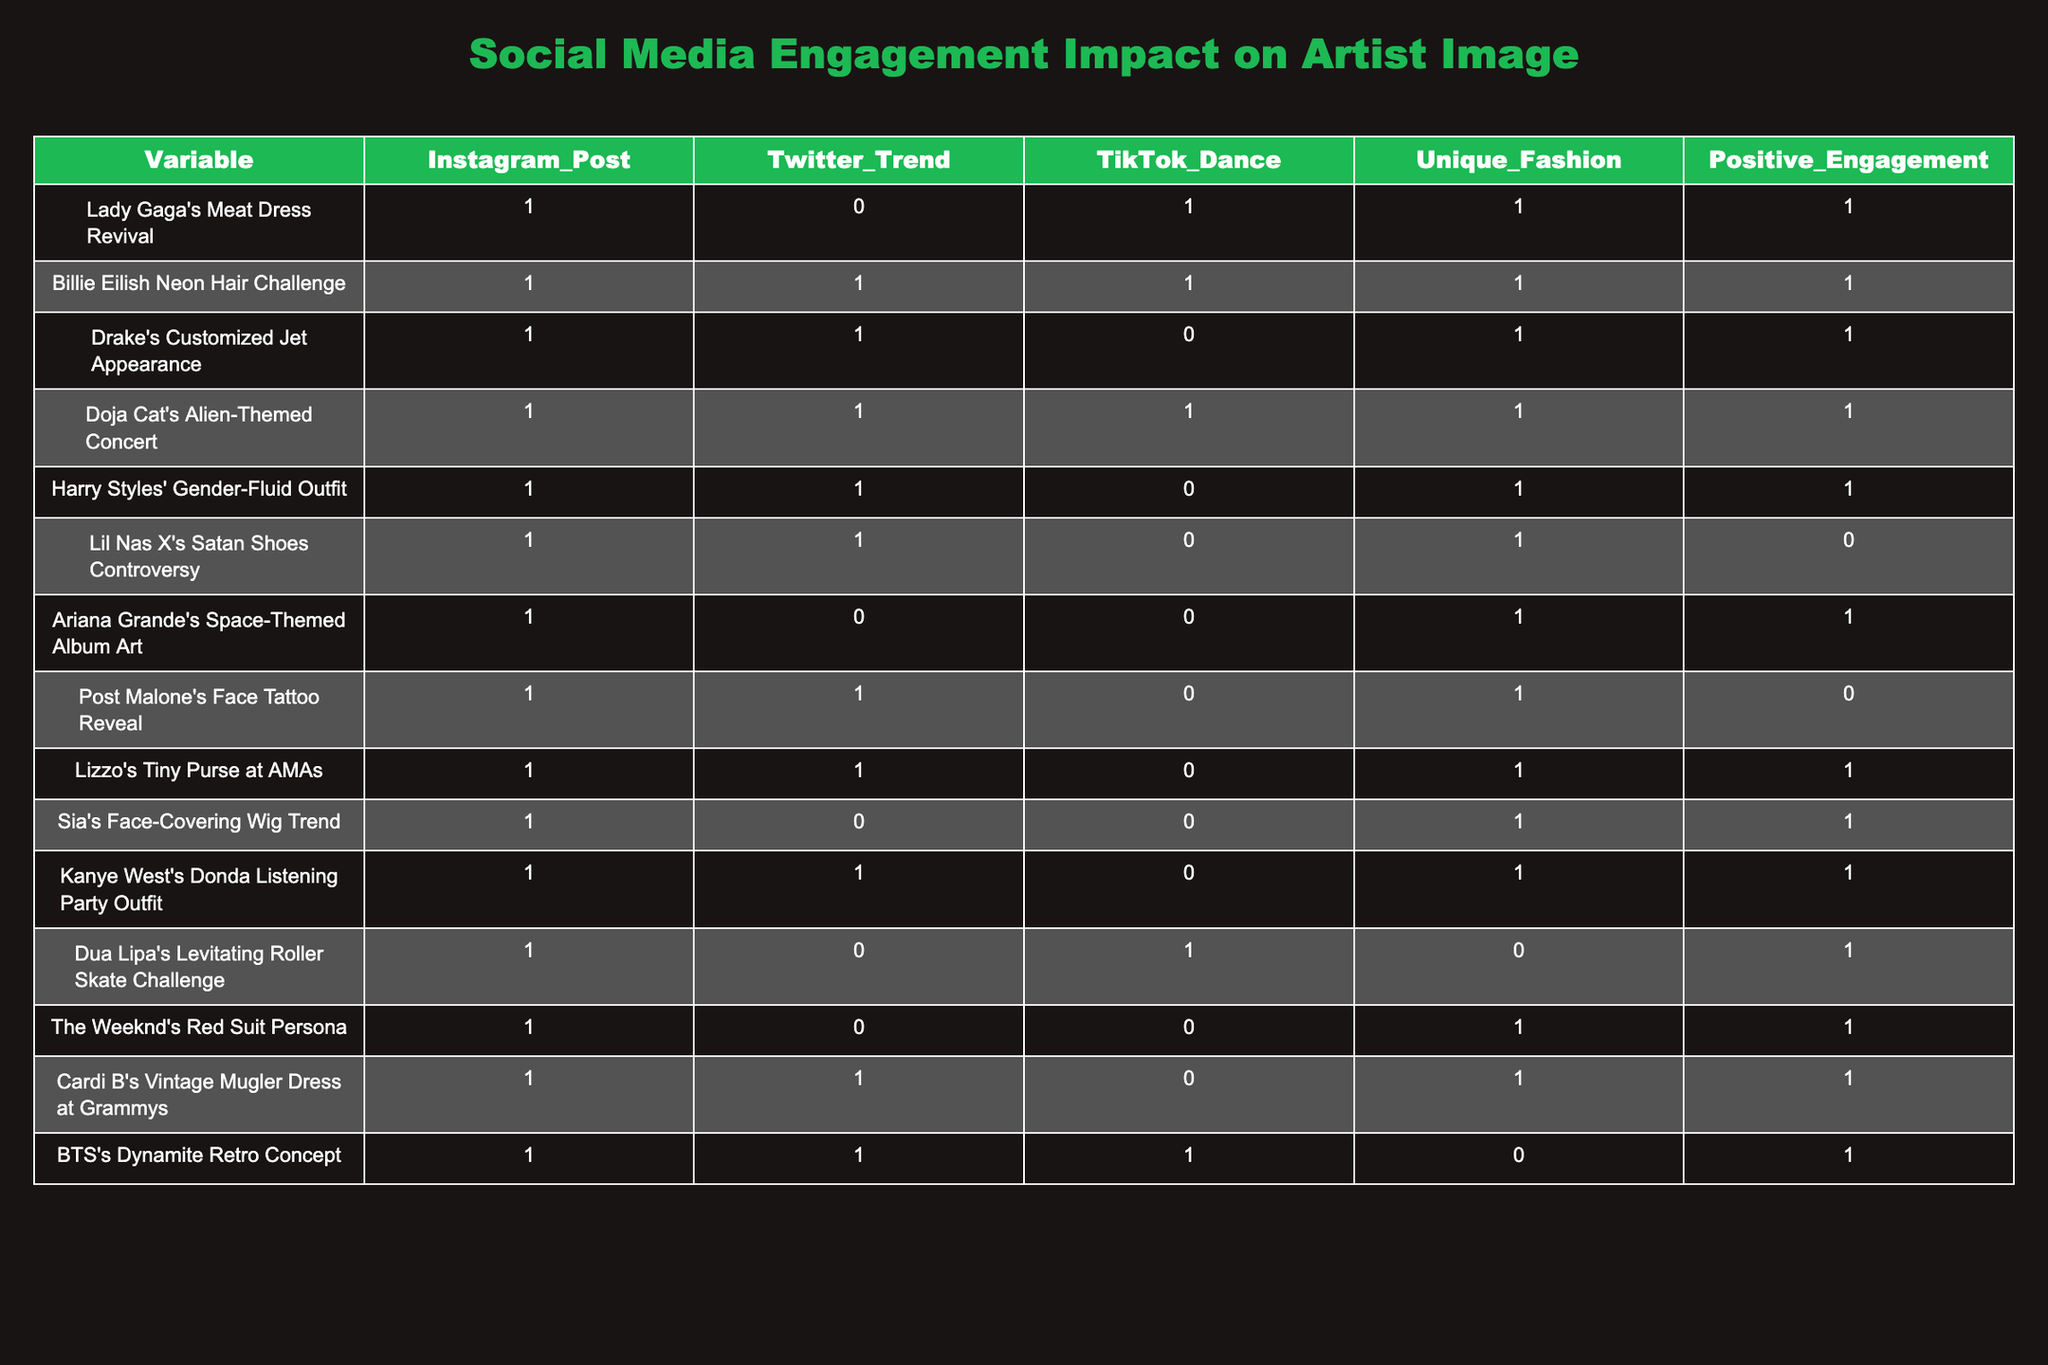What is the total count of posts that have unique fashion? By looking through the Unique Fashion column, I can count the total number of rows that have a value of 1. The relevant rows are: Lady Gaga's Meat Dress Revival, Billie Eilish Neon Hair Challenge, Drake's Customized Jet Appearance, Doja Cat's Alien-Themed Concert, Harry Styles' Gender-Fluid Outfit, Ariana Grande's Space-Themed Album Art, Sia's Face-Covering Wig Trend, Kanye West's Donda Listening Party Outfit, and Cardi B's Vintage Mugler Dress at Grammys. That gives us a count of 9 posts.
Answer: 9 Which artist had a positive engagement without using TikTok? To find this, we need to check the Positive Engagement column for a value of 1, while also ensuring that the corresponding TikTok Dance column has a value of 0. Checking through the table reveals that Ariana Grande's Space-Themed Album Art and Sia's Face-Covering Wig Trend meet these criteria. Therefore, the answer includes these two artists.
Answer: Ariana Grande, Sia What is the percentage of posts with positive engagement out of the total posts? There are 12 total posts, and 8 of them have Positive Engagement equaling 1. To find the percentage, I use the formula (Number of Positive Engagement Posts / Total Posts) * 100. This gives me (8/12) * 100 = 66.67%.
Answer: 66.67% Can we confirm whether Billie Eilish's Neon Hair Challenge has both a positive engagement and all social media trends? Reviewing Billie Eilish's Neon Hair Challenge: it has values of 1 for Instagram Post, Twitter Trend, TikTok Dance, and positive engagement. Therefore, it confirms that this post has high engagement in all the respective areas.
Answer: Yes Which artists have made fashion statements while also having positive engagement? To answer this, I check which rows have both Unique Fashion as 1 and Positive Engagement as 1. Those are Lady Gaga, Billie Eilish, Drake, Doja Cat, Harry Styles, Lizzo, Kanye West, and Cardi B. This gives a total of 8 artists who made fashion statements with positive engagement.
Answer: 8 